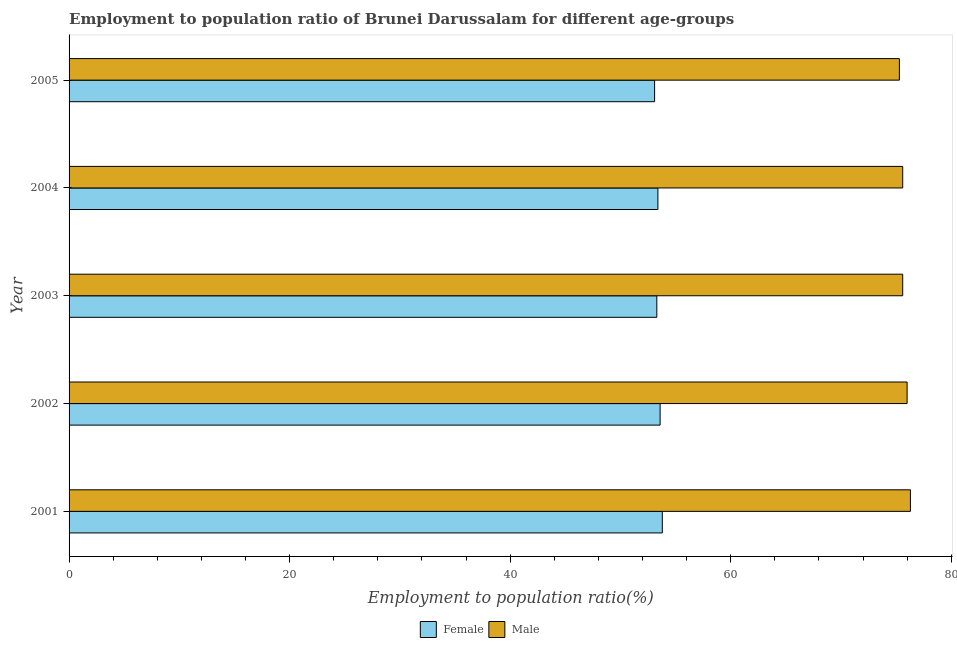How many different coloured bars are there?
Provide a short and direct response. 2. How many groups of bars are there?
Keep it short and to the point. 5. Are the number of bars per tick equal to the number of legend labels?
Your answer should be very brief. Yes. Are the number of bars on each tick of the Y-axis equal?
Provide a succinct answer. Yes. How many bars are there on the 2nd tick from the bottom?
Offer a terse response. 2. In how many cases, is the number of bars for a given year not equal to the number of legend labels?
Provide a short and direct response. 0. What is the employment to population ratio(female) in 2004?
Offer a terse response. 53.4. Across all years, what is the maximum employment to population ratio(female)?
Ensure brevity in your answer.  53.8. Across all years, what is the minimum employment to population ratio(male)?
Keep it short and to the point. 75.3. In which year was the employment to population ratio(male) maximum?
Provide a short and direct response. 2001. In which year was the employment to population ratio(female) minimum?
Provide a succinct answer. 2005. What is the total employment to population ratio(female) in the graph?
Offer a terse response. 267.2. What is the difference between the employment to population ratio(female) in 2002 and the employment to population ratio(male) in 2004?
Your answer should be compact. -22. What is the average employment to population ratio(male) per year?
Provide a succinct answer. 75.76. In the year 2003, what is the difference between the employment to population ratio(female) and employment to population ratio(male)?
Keep it short and to the point. -22.3. In how many years, is the employment to population ratio(male) greater than 36 %?
Ensure brevity in your answer.  5. Is the employment to population ratio(male) in 2002 less than that in 2004?
Provide a succinct answer. No. Is the difference between the employment to population ratio(female) in 2004 and 2005 greater than the difference between the employment to population ratio(male) in 2004 and 2005?
Give a very brief answer. Yes. What is the difference between the highest and the second highest employment to population ratio(male)?
Offer a terse response. 0.3. What is the difference between the highest and the lowest employment to population ratio(female)?
Make the answer very short. 0.7. In how many years, is the employment to population ratio(male) greater than the average employment to population ratio(male) taken over all years?
Make the answer very short. 2. How many bars are there?
Provide a succinct answer. 10. How many years are there in the graph?
Give a very brief answer. 5. What is the difference between two consecutive major ticks on the X-axis?
Your answer should be compact. 20. Does the graph contain grids?
Your answer should be very brief. No. What is the title of the graph?
Give a very brief answer. Employment to population ratio of Brunei Darussalam for different age-groups. Does "Domestic Liabilities" appear as one of the legend labels in the graph?
Give a very brief answer. No. What is the Employment to population ratio(%) in Female in 2001?
Give a very brief answer. 53.8. What is the Employment to population ratio(%) in Male in 2001?
Provide a succinct answer. 76.3. What is the Employment to population ratio(%) in Female in 2002?
Offer a terse response. 53.6. What is the Employment to population ratio(%) of Male in 2002?
Your answer should be compact. 76. What is the Employment to population ratio(%) in Female in 2003?
Give a very brief answer. 53.3. What is the Employment to population ratio(%) in Male in 2003?
Your answer should be compact. 75.6. What is the Employment to population ratio(%) in Female in 2004?
Make the answer very short. 53.4. What is the Employment to population ratio(%) of Male in 2004?
Provide a succinct answer. 75.6. What is the Employment to population ratio(%) of Female in 2005?
Provide a succinct answer. 53.1. What is the Employment to population ratio(%) of Male in 2005?
Offer a very short reply. 75.3. Across all years, what is the maximum Employment to population ratio(%) of Female?
Provide a short and direct response. 53.8. Across all years, what is the maximum Employment to population ratio(%) in Male?
Give a very brief answer. 76.3. Across all years, what is the minimum Employment to population ratio(%) in Female?
Offer a terse response. 53.1. Across all years, what is the minimum Employment to population ratio(%) of Male?
Your answer should be compact. 75.3. What is the total Employment to population ratio(%) of Female in the graph?
Your answer should be compact. 267.2. What is the total Employment to population ratio(%) of Male in the graph?
Your response must be concise. 378.8. What is the difference between the Employment to population ratio(%) in Female in 2001 and that in 2003?
Offer a terse response. 0.5. What is the difference between the Employment to population ratio(%) in Male in 2001 and that in 2004?
Provide a short and direct response. 0.7. What is the difference between the Employment to population ratio(%) of Male in 2001 and that in 2005?
Give a very brief answer. 1. What is the difference between the Employment to population ratio(%) of Female in 2002 and that in 2003?
Provide a succinct answer. 0.3. What is the difference between the Employment to population ratio(%) of Male in 2002 and that in 2003?
Provide a succinct answer. 0.4. What is the difference between the Employment to population ratio(%) in Female in 2002 and that in 2004?
Your answer should be very brief. 0.2. What is the difference between the Employment to population ratio(%) in Female in 2002 and that in 2005?
Offer a terse response. 0.5. What is the difference between the Employment to population ratio(%) of Male in 2003 and that in 2004?
Provide a succinct answer. 0. What is the difference between the Employment to population ratio(%) in Female in 2001 and the Employment to population ratio(%) in Male in 2002?
Provide a succinct answer. -22.2. What is the difference between the Employment to population ratio(%) of Female in 2001 and the Employment to population ratio(%) of Male in 2003?
Your answer should be very brief. -21.8. What is the difference between the Employment to population ratio(%) of Female in 2001 and the Employment to population ratio(%) of Male in 2004?
Provide a succinct answer. -21.8. What is the difference between the Employment to population ratio(%) in Female in 2001 and the Employment to population ratio(%) in Male in 2005?
Give a very brief answer. -21.5. What is the difference between the Employment to population ratio(%) in Female in 2002 and the Employment to population ratio(%) in Male in 2003?
Your answer should be compact. -22. What is the difference between the Employment to population ratio(%) in Female in 2002 and the Employment to population ratio(%) in Male in 2005?
Offer a terse response. -21.7. What is the difference between the Employment to population ratio(%) in Female in 2003 and the Employment to population ratio(%) in Male in 2004?
Your answer should be compact. -22.3. What is the difference between the Employment to population ratio(%) in Female in 2004 and the Employment to population ratio(%) in Male in 2005?
Provide a succinct answer. -21.9. What is the average Employment to population ratio(%) in Female per year?
Give a very brief answer. 53.44. What is the average Employment to population ratio(%) of Male per year?
Give a very brief answer. 75.76. In the year 2001, what is the difference between the Employment to population ratio(%) in Female and Employment to population ratio(%) in Male?
Your answer should be very brief. -22.5. In the year 2002, what is the difference between the Employment to population ratio(%) in Female and Employment to population ratio(%) in Male?
Make the answer very short. -22.4. In the year 2003, what is the difference between the Employment to population ratio(%) of Female and Employment to population ratio(%) of Male?
Your response must be concise. -22.3. In the year 2004, what is the difference between the Employment to population ratio(%) of Female and Employment to population ratio(%) of Male?
Keep it short and to the point. -22.2. In the year 2005, what is the difference between the Employment to population ratio(%) of Female and Employment to population ratio(%) of Male?
Provide a succinct answer. -22.2. What is the ratio of the Employment to population ratio(%) of Male in 2001 to that in 2002?
Make the answer very short. 1. What is the ratio of the Employment to population ratio(%) of Female in 2001 to that in 2003?
Make the answer very short. 1.01. What is the ratio of the Employment to population ratio(%) in Male in 2001 to that in 2003?
Provide a short and direct response. 1.01. What is the ratio of the Employment to population ratio(%) in Female in 2001 to that in 2004?
Keep it short and to the point. 1.01. What is the ratio of the Employment to population ratio(%) in Male in 2001 to that in 2004?
Offer a terse response. 1.01. What is the ratio of the Employment to population ratio(%) of Female in 2001 to that in 2005?
Provide a succinct answer. 1.01. What is the ratio of the Employment to population ratio(%) of Male in 2001 to that in 2005?
Provide a succinct answer. 1.01. What is the ratio of the Employment to population ratio(%) of Female in 2002 to that in 2003?
Provide a succinct answer. 1.01. What is the ratio of the Employment to population ratio(%) in Female in 2002 to that in 2005?
Give a very brief answer. 1.01. What is the ratio of the Employment to population ratio(%) in Male in 2002 to that in 2005?
Your answer should be compact. 1.01. What is the ratio of the Employment to population ratio(%) of Female in 2003 to that in 2004?
Your answer should be compact. 1. What is the ratio of the Employment to population ratio(%) in Male in 2003 to that in 2005?
Your response must be concise. 1. What is the ratio of the Employment to population ratio(%) of Female in 2004 to that in 2005?
Provide a short and direct response. 1.01. What is the ratio of the Employment to population ratio(%) of Male in 2004 to that in 2005?
Your response must be concise. 1. What is the difference between the highest and the second highest Employment to population ratio(%) of Female?
Your answer should be very brief. 0.2. 